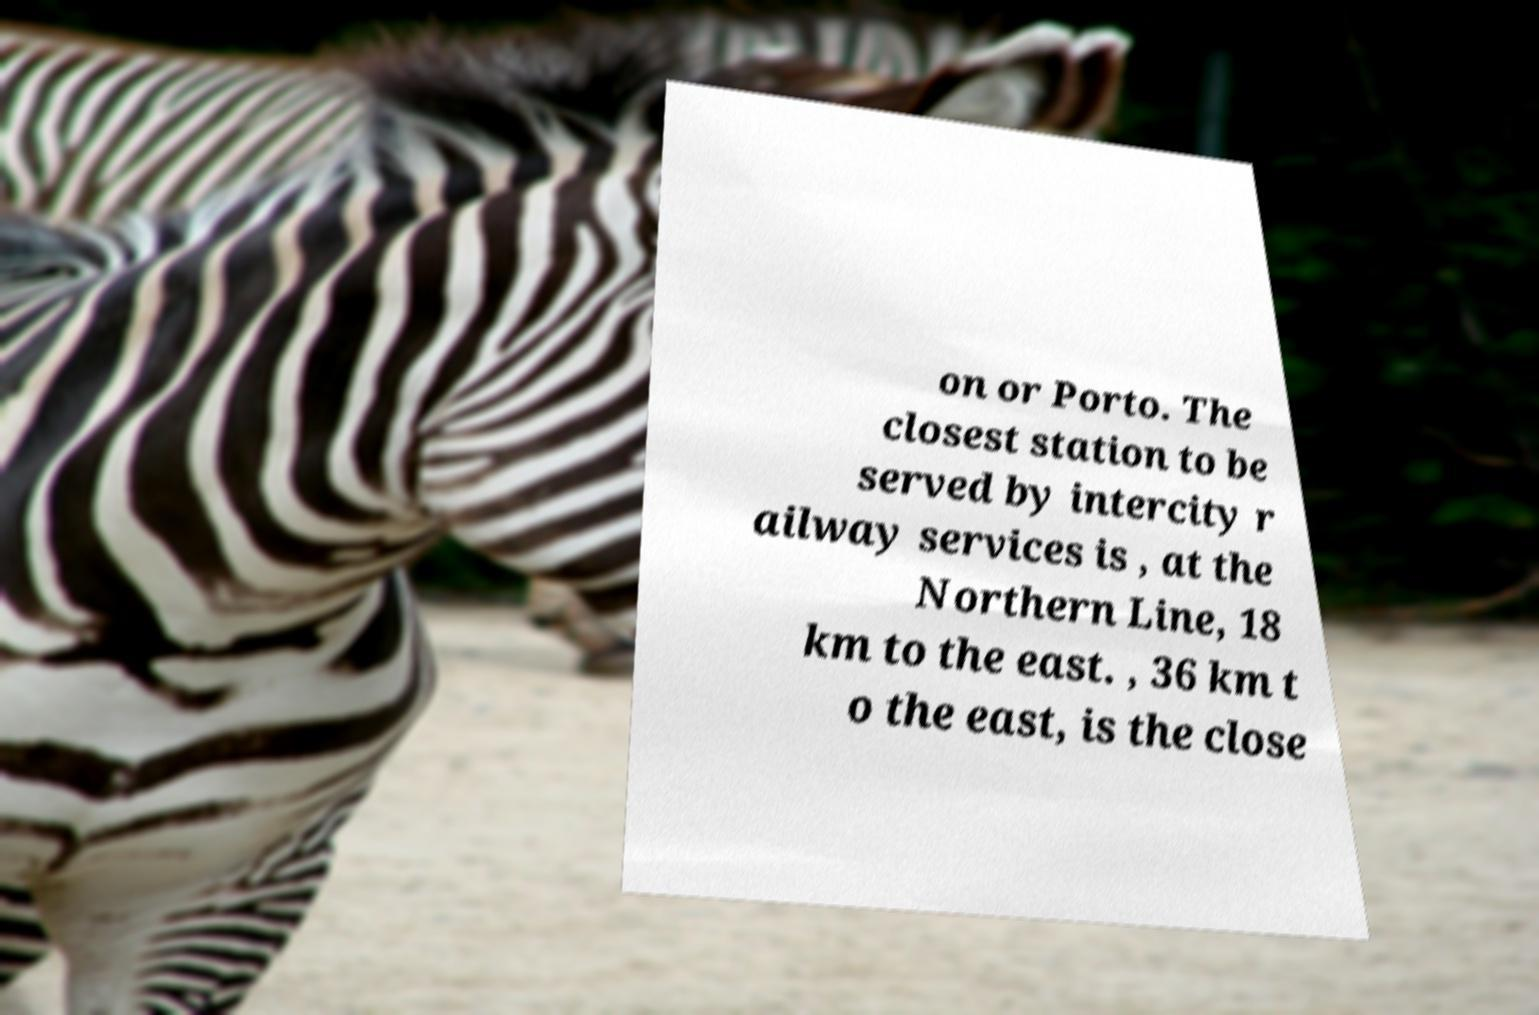Please identify and transcribe the text found in this image. on or Porto. The closest station to be served by intercity r ailway services is , at the Northern Line, 18 km to the east. , 36 km t o the east, is the close 